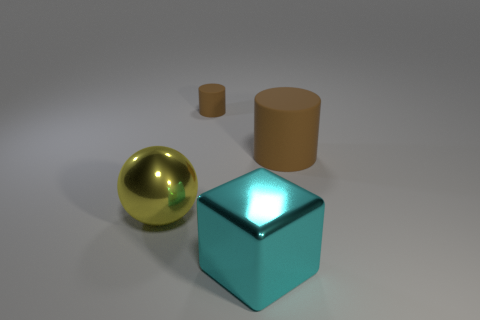Add 4 rubber objects. How many objects exist? 8 Subtract 0 blue blocks. How many objects are left? 4 Subtract all spheres. How many objects are left? 3 Subtract all large yellow matte cylinders. Subtract all large cyan metal objects. How many objects are left? 3 Add 1 matte things. How many matte things are left? 3 Add 1 blocks. How many blocks exist? 2 